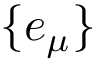Convert formula to latex. <formula><loc_0><loc_0><loc_500><loc_500>\{ e _ { \mu } \}</formula> 